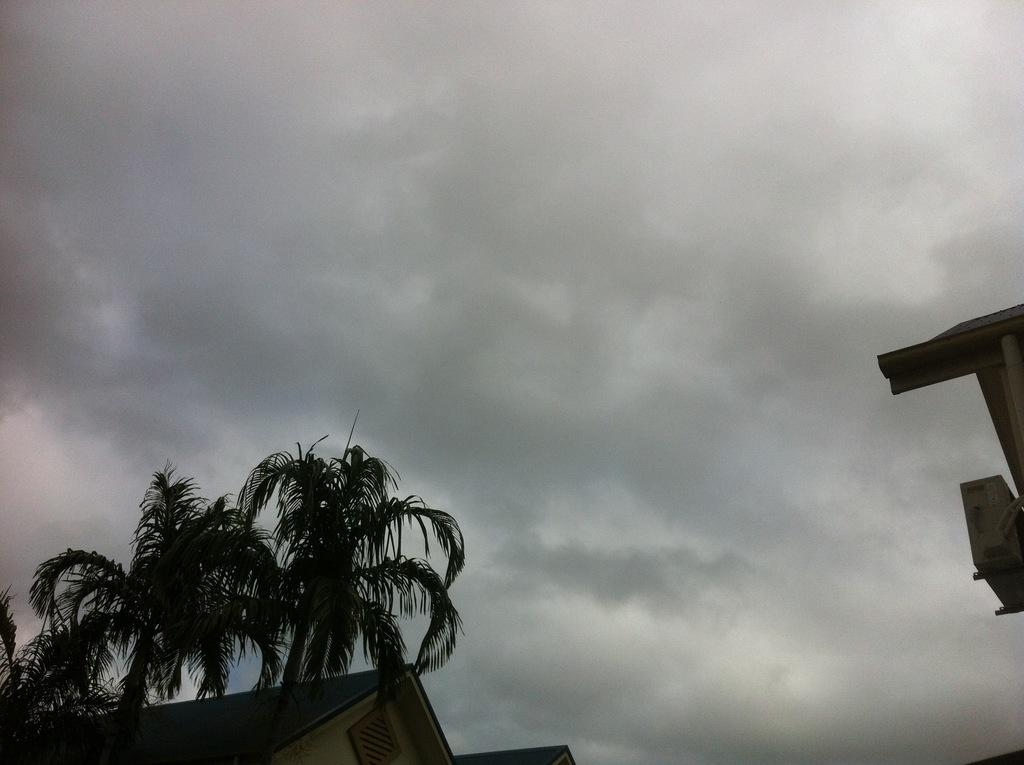How many houses are visible in the image? There are two structures in the image that resemble houses. What is located in front of the houses? There are trees in front of the houses. What can be seen behind the houses? The sky is visible behind the houses and appears to be cloudy. What type of skirt is the passenger wearing in the image? There is no passenger or skirt present in the image. Can you describe the tongue of the person in the image? There is no person or tongue present in the image. 